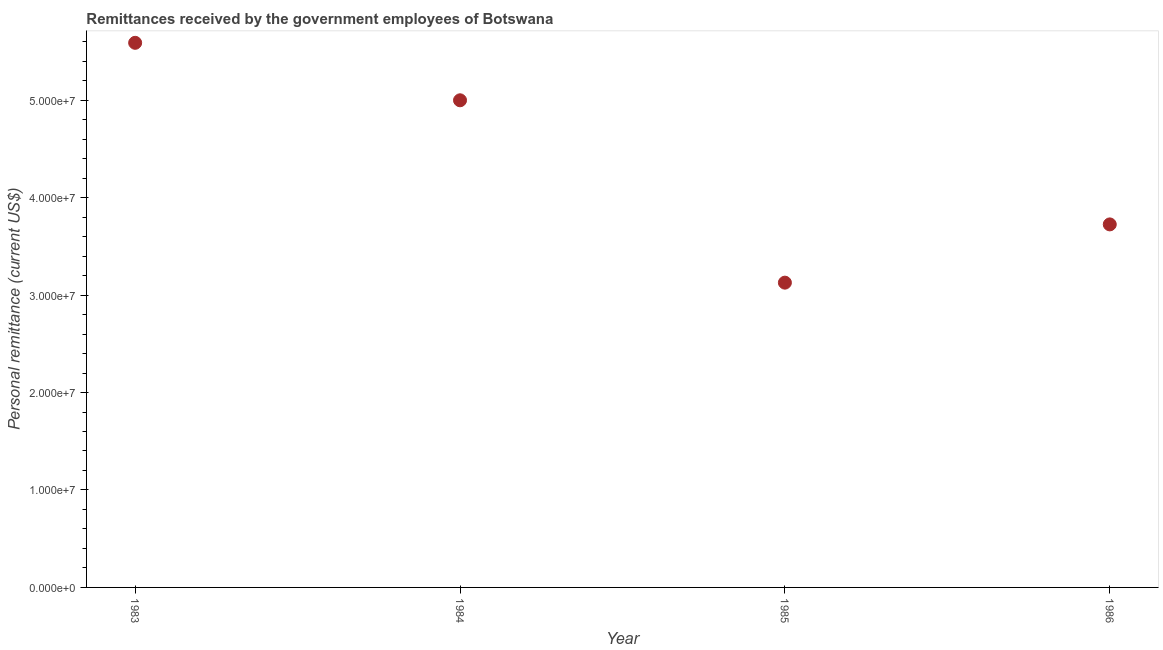What is the personal remittances in 1985?
Offer a very short reply. 3.13e+07. Across all years, what is the maximum personal remittances?
Make the answer very short. 5.59e+07. Across all years, what is the minimum personal remittances?
Offer a terse response. 3.13e+07. What is the sum of the personal remittances?
Keep it short and to the point. 1.74e+08. What is the difference between the personal remittances in 1983 and 1986?
Provide a succinct answer. 1.86e+07. What is the average personal remittances per year?
Your answer should be compact. 4.36e+07. What is the median personal remittances?
Offer a terse response. 4.36e+07. In how many years, is the personal remittances greater than 52000000 US$?
Offer a very short reply. 1. Do a majority of the years between 1983 and 1985 (inclusive) have personal remittances greater than 52000000 US$?
Keep it short and to the point. No. What is the ratio of the personal remittances in 1983 to that in 1986?
Give a very brief answer. 1.5. Is the difference between the personal remittances in 1985 and 1986 greater than the difference between any two years?
Keep it short and to the point. No. What is the difference between the highest and the second highest personal remittances?
Keep it short and to the point. 5.90e+06. Is the sum of the personal remittances in 1984 and 1985 greater than the maximum personal remittances across all years?
Offer a very short reply. Yes. What is the difference between the highest and the lowest personal remittances?
Your answer should be very brief. 2.46e+07. In how many years, is the personal remittances greater than the average personal remittances taken over all years?
Your answer should be very brief. 2. How many years are there in the graph?
Your response must be concise. 4. What is the difference between two consecutive major ticks on the Y-axis?
Ensure brevity in your answer.  1.00e+07. Does the graph contain any zero values?
Your response must be concise. No. What is the title of the graph?
Keep it short and to the point. Remittances received by the government employees of Botswana. What is the label or title of the X-axis?
Keep it short and to the point. Year. What is the label or title of the Y-axis?
Offer a terse response. Personal remittance (current US$). What is the Personal remittance (current US$) in 1983?
Your answer should be very brief. 5.59e+07. What is the Personal remittance (current US$) in 1984?
Offer a very short reply. 5.00e+07. What is the Personal remittance (current US$) in 1985?
Provide a succinct answer. 3.13e+07. What is the Personal remittance (current US$) in 1986?
Give a very brief answer. 3.73e+07. What is the difference between the Personal remittance (current US$) in 1983 and 1984?
Your response must be concise. 5.90e+06. What is the difference between the Personal remittance (current US$) in 1983 and 1985?
Offer a terse response. 2.46e+07. What is the difference between the Personal remittance (current US$) in 1983 and 1986?
Provide a succinct answer. 1.86e+07. What is the difference between the Personal remittance (current US$) in 1984 and 1985?
Provide a short and direct response. 1.87e+07. What is the difference between the Personal remittance (current US$) in 1984 and 1986?
Offer a very short reply. 1.27e+07. What is the difference between the Personal remittance (current US$) in 1985 and 1986?
Offer a very short reply. -5.98e+06. What is the ratio of the Personal remittance (current US$) in 1983 to that in 1984?
Offer a very short reply. 1.12. What is the ratio of the Personal remittance (current US$) in 1983 to that in 1985?
Keep it short and to the point. 1.79. What is the ratio of the Personal remittance (current US$) in 1984 to that in 1985?
Keep it short and to the point. 1.6. What is the ratio of the Personal remittance (current US$) in 1984 to that in 1986?
Provide a short and direct response. 1.34. What is the ratio of the Personal remittance (current US$) in 1985 to that in 1986?
Provide a short and direct response. 0.84. 